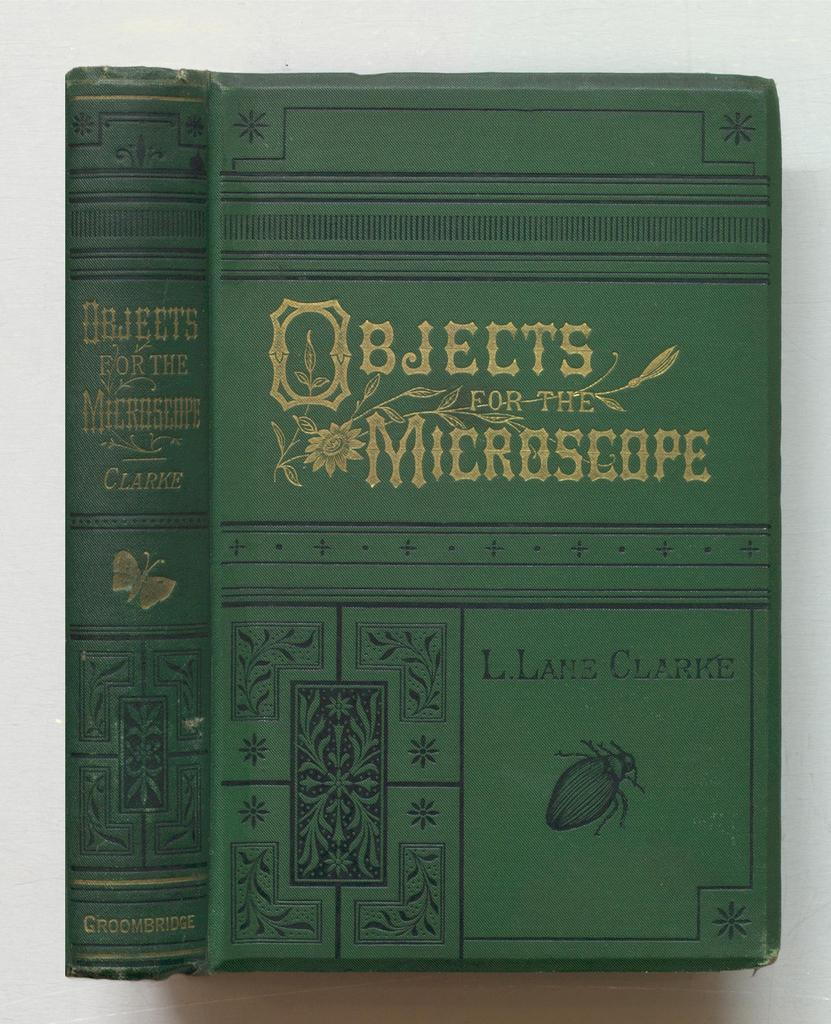<image>
Present a compact description of the photo's key features. A green book is titled Objects for the Microscope. 